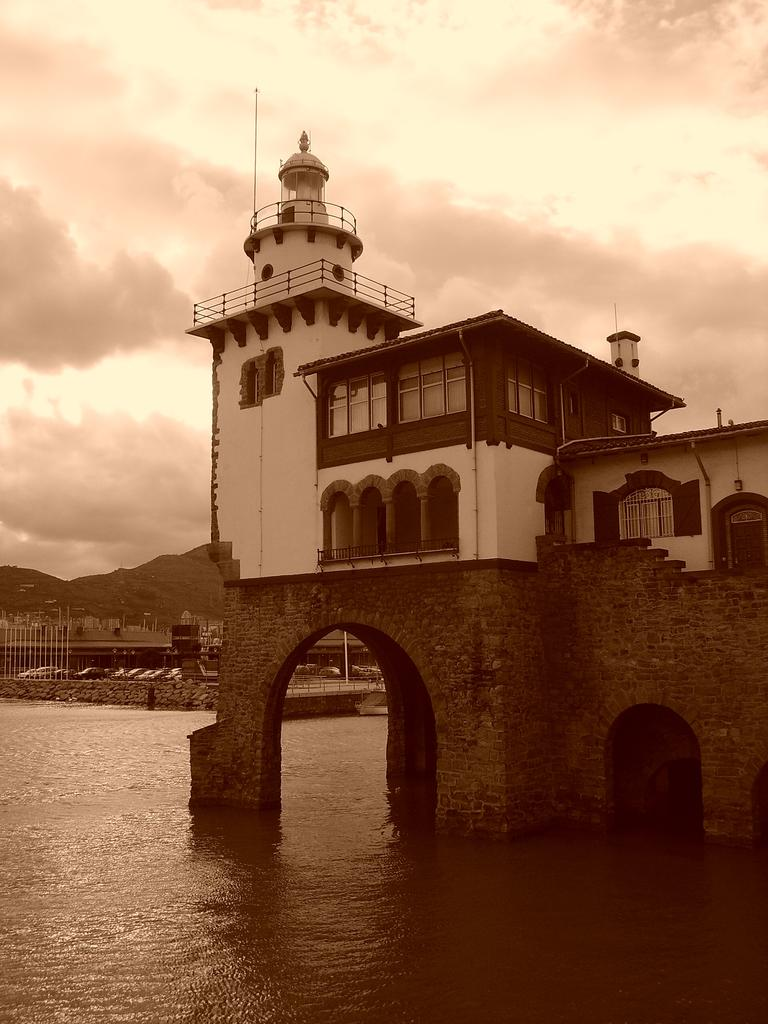What type of structure is visible in the image? There is a building with windows in the image. What architectural features can be seen on the building? The building has pillars. What else is present in the image besides the building? There is a wall, water, a group of vehicles, and poles visible in the image. What is the condition of the sky in the image? The sky is visible and appears cloudy. Can you see any fairies flying around the building in the image? There are no fairies present in the image. What type of bubble can be seen floating near the water in the image? There is no bubble visible in the image. 